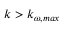<formula> <loc_0><loc_0><loc_500><loc_500>k > k _ { \omega , \max }</formula> 